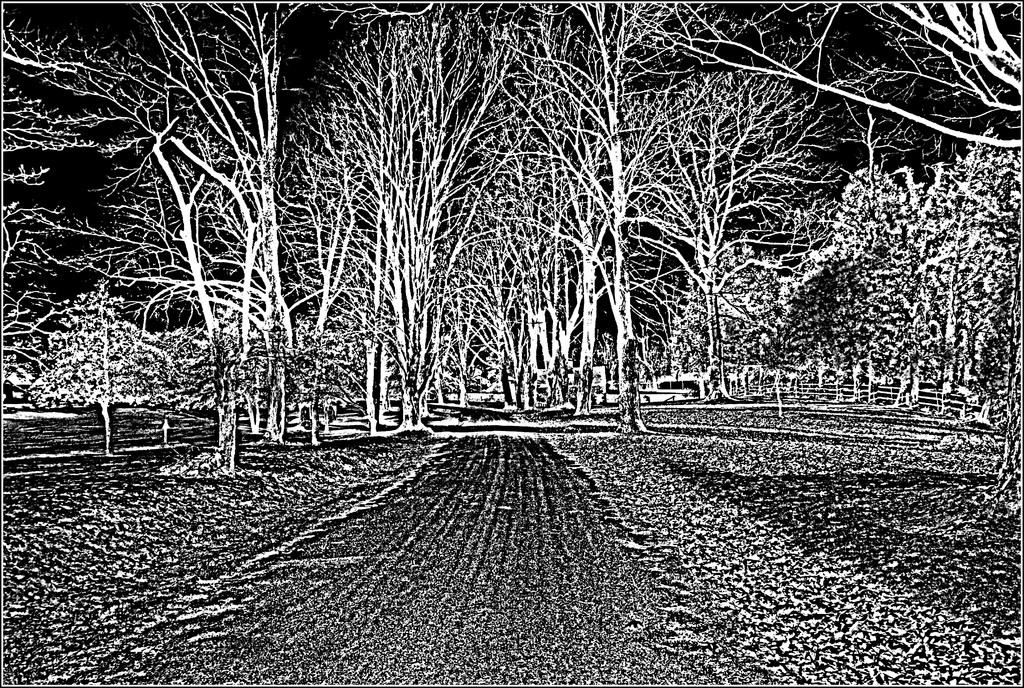What is the color scheme of the image? The image is black and white. What type of objects can be seen in the image? There are trees in the image. Has the image been altered in any way? Yes, the image is edited. Can you see any plants being pulled in the alley in the image? There is no alley or plants being pulled in the image; it features trees in a black and white, edited format. 